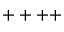Convert formula to latex. <formula><loc_0><loc_0><loc_500><loc_500>+ + + +</formula> 